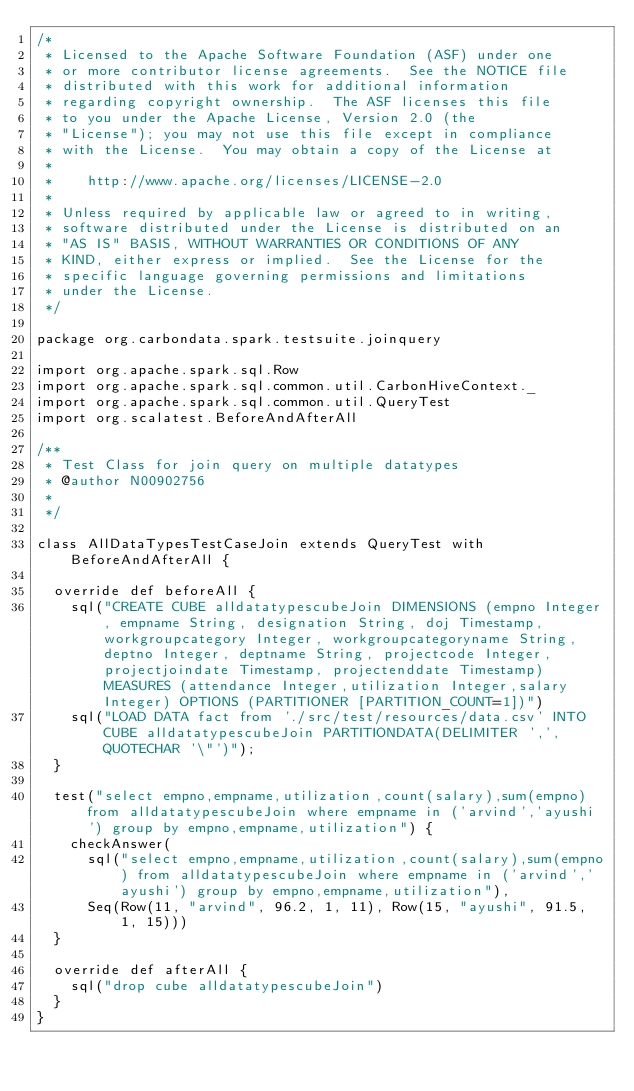Convert code to text. <code><loc_0><loc_0><loc_500><loc_500><_Scala_>/*
 * Licensed to the Apache Software Foundation (ASF) under one
 * or more contributor license agreements.  See the NOTICE file
 * distributed with this work for additional information
 * regarding copyright ownership.  The ASF licenses this file
 * to you under the Apache License, Version 2.0 (the
 * "License"); you may not use this file except in compliance
 * with the License.  You may obtain a copy of the License at
 *
 *    http://www.apache.org/licenses/LICENSE-2.0
 *
 * Unless required by applicable law or agreed to in writing,
 * software distributed under the License is distributed on an
 * "AS IS" BASIS, WITHOUT WARRANTIES OR CONDITIONS OF ANY
 * KIND, either express or implied.  See the License for the
 * specific language governing permissions and limitations
 * under the License.
 */

package org.carbondata.spark.testsuite.joinquery

import org.apache.spark.sql.Row
import org.apache.spark.sql.common.util.CarbonHiveContext._
import org.apache.spark.sql.common.util.QueryTest
import org.scalatest.BeforeAndAfterAll

/**
 * Test Class for join query on multiple datatypes
 * @author N00902756
 *
 */

class AllDataTypesTestCaseJoin extends QueryTest with BeforeAndAfterAll {

  override def beforeAll {
    sql("CREATE CUBE alldatatypescubeJoin DIMENSIONS (empno Integer, empname String, designation String, doj Timestamp, workgroupcategory Integer, workgroupcategoryname String, deptno Integer, deptname String, projectcode Integer, projectjoindate Timestamp, projectenddate Timestamp) MEASURES (attendance Integer,utilization Integer,salary Integer) OPTIONS (PARTITIONER [PARTITION_COUNT=1])")
    sql("LOAD DATA fact from './src/test/resources/data.csv' INTO CUBE alldatatypescubeJoin PARTITIONDATA(DELIMITER ',', QUOTECHAR '\"')");
  }

  test("select empno,empname,utilization,count(salary),sum(empno) from alldatatypescubeJoin where empname in ('arvind','ayushi') group by empno,empname,utilization") {
    checkAnswer(
      sql("select empno,empname,utilization,count(salary),sum(empno) from alldatatypescubeJoin where empname in ('arvind','ayushi') group by empno,empname,utilization"),
      Seq(Row(11, "arvind", 96.2, 1, 11), Row(15, "ayushi", 91.5, 1, 15)))
  }

  override def afterAll {
    sql("drop cube alldatatypescubeJoin")
  }
}</code> 